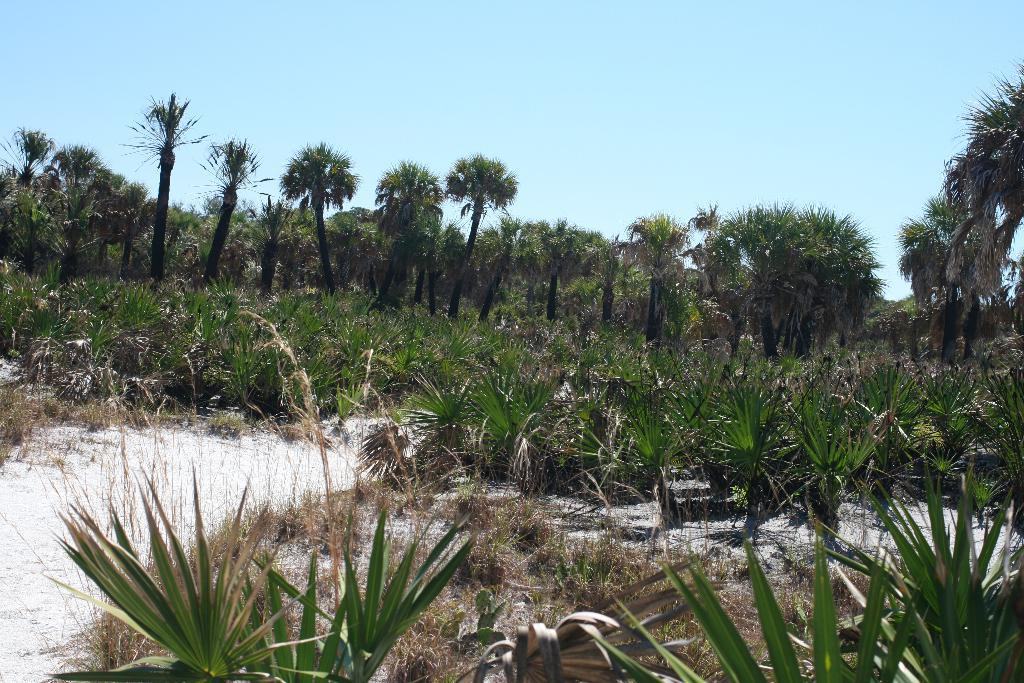What type of vegetation is present at the bottom of the image? There are plants and grass at the bottom of the image. What is the ground made of at the bottom of the image? The ground at the bottom of the image is covered with grass. What can be seen in the background of the image? There are trees and the sky visible in the background of the image. What type of building is visible in the image? There is no building present in the image; it features plants, grass, trees, and the sky. What kind of feast is being prepared in the image? There is no feast or any indication of food preparation in the image. 